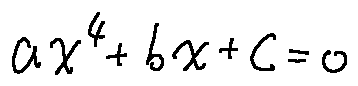<formula> <loc_0><loc_0><loc_500><loc_500>a x ^ { 4 } + b x + c = 0</formula> 